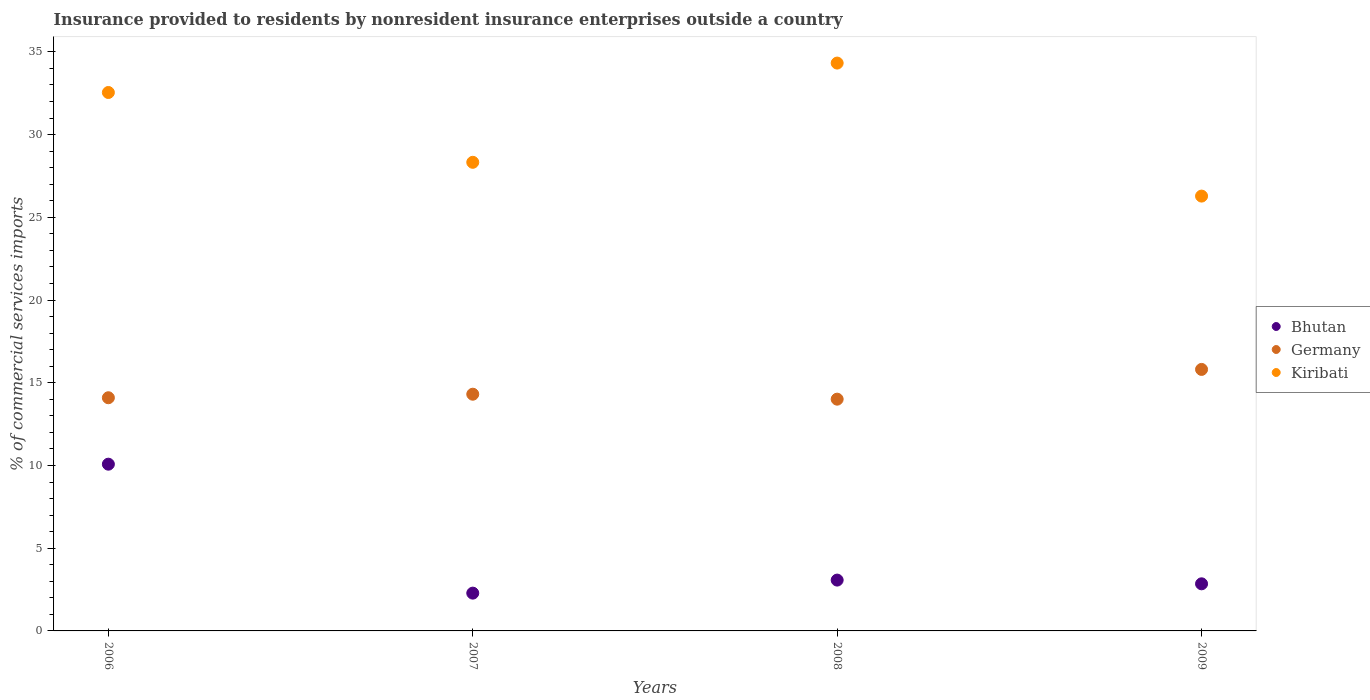What is the Insurance provided to residents in Kiribati in 2008?
Make the answer very short. 34.32. Across all years, what is the maximum Insurance provided to residents in Germany?
Your response must be concise. 15.81. Across all years, what is the minimum Insurance provided to residents in Kiribati?
Offer a very short reply. 26.28. In which year was the Insurance provided to residents in Bhutan minimum?
Make the answer very short. 2007. What is the total Insurance provided to residents in Bhutan in the graph?
Your answer should be compact. 18.28. What is the difference between the Insurance provided to residents in Bhutan in 2007 and that in 2008?
Provide a short and direct response. -0.79. What is the difference between the Insurance provided to residents in Germany in 2006 and the Insurance provided to residents in Kiribati in 2009?
Ensure brevity in your answer.  -12.19. What is the average Insurance provided to residents in Germany per year?
Ensure brevity in your answer.  14.55. In the year 2009, what is the difference between the Insurance provided to residents in Kiribati and Insurance provided to residents in Germany?
Keep it short and to the point. 10.48. What is the ratio of the Insurance provided to residents in Kiribati in 2006 to that in 2007?
Your answer should be very brief. 1.15. What is the difference between the highest and the second highest Insurance provided to residents in Kiribati?
Provide a short and direct response. 1.78. What is the difference between the highest and the lowest Insurance provided to residents in Kiribati?
Provide a short and direct response. 8.04. In how many years, is the Insurance provided to residents in Bhutan greater than the average Insurance provided to residents in Bhutan taken over all years?
Your answer should be compact. 1. How many dotlines are there?
Provide a short and direct response. 3. What is the difference between two consecutive major ticks on the Y-axis?
Your answer should be very brief. 5. Are the values on the major ticks of Y-axis written in scientific E-notation?
Offer a terse response. No. Does the graph contain any zero values?
Offer a very short reply. No. How many legend labels are there?
Make the answer very short. 3. What is the title of the graph?
Your answer should be compact. Insurance provided to residents by nonresident insurance enterprises outside a country. Does "East Asia (all income levels)" appear as one of the legend labels in the graph?
Offer a very short reply. No. What is the label or title of the Y-axis?
Make the answer very short. % of commercial services imports. What is the % of commercial services imports of Bhutan in 2006?
Keep it short and to the point. 10.08. What is the % of commercial services imports of Germany in 2006?
Ensure brevity in your answer.  14.09. What is the % of commercial services imports in Kiribati in 2006?
Provide a succinct answer. 32.55. What is the % of commercial services imports in Bhutan in 2007?
Give a very brief answer. 2.28. What is the % of commercial services imports of Germany in 2007?
Offer a very short reply. 14.31. What is the % of commercial services imports of Kiribati in 2007?
Make the answer very short. 28.33. What is the % of commercial services imports in Bhutan in 2008?
Provide a short and direct response. 3.07. What is the % of commercial services imports of Germany in 2008?
Your answer should be compact. 14.01. What is the % of commercial services imports in Kiribati in 2008?
Your response must be concise. 34.32. What is the % of commercial services imports in Bhutan in 2009?
Keep it short and to the point. 2.85. What is the % of commercial services imports in Germany in 2009?
Your answer should be compact. 15.81. What is the % of commercial services imports in Kiribati in 2009?
Offer a very short reply. 26.28. Across all years, what is the maximum % of commercial services imports in Bhutan?
Your answer should be very brief. 10.08. Across all years, what is the maximum % of commercial services imports in Germany?
Provide a succinct answer. 15.81. Across all years, what is the maximum % of commercial services imports of Kiribati?
Ensure brevity in your answer.  34.32. Across all years, what is the minimum % of commercial services imports in Bhutan?
Provide a short and direct response. 2.28. Across all years, what is the minimum % of commercial services imports of Germany?
Provide a short and direct response. 14.01. Across all years, what is the minimum % of commercial services imports of Kiribati?
Provide a short and direct response. 26.28. What is the total % of commercial services imports in Bhutan in the graph?
Offer a very short reply. 18.28. What is the total % of commercial services imports of Germany in the graph?
Make the answer very short. 58.22. What is the total % of commercial services imports in Kiribati in the graph?
Give a very brief answer. 121.48. What is the difference between the % of commercial services imports in Bhutan in 2006 and that in 2007?
Ensure brevity in your answer.  7.79. What is the difference between the % of commercial services imports in Germany in 2006 and that in 2007?
Your answer should be compact. -0.21. What is the difference between the % of commercial services imports of Kiribati in 2006 and that in 2007?
Offer a very short reply. 4.22. What is the difference between the % of commercial services imports of Bhutan in 2006 and that in 2008?
Keep it short and to the point. 7.01. What is the difference between the % of commercial services imports of Germany in 2006 and that in 2008?
Offer a terse response. 0.09. What is the difference between the % of commercial services imports of Kiribati in 2006 and that in 2008?
Your answer should be very brief. -1.78. What is the difference between the % of commercial services imports of Bhutan in 2006 and that in 2009?
Your answer should be compact. 7.23. What is the difference between the % of commercial services imports of Germany in 2006 and that in 2009?
Your answer should be compact. -1.71. What is the difference between the % of commercial services imports in Kiribati in 2006 and that in 2009?
Make the answer very short. 6.26. What is the difference between the % of commercial services imports in Bhutan in 2007 and that in 2008?
Your answer should be very brief. -0.79. What is the difference between the % of commercial services imports of Germany in 2007 and that in 2008?
Your response must be concise. 0.3. What is the difference between the % of commercial services imports of Kiribati in 2007 and that in 2008?
Provide a succinct answer. -6. What is the difference between the % of commercial services imports of Bhutan in 2007 and that in 2009?
Keep it short and to the point. -0.56. What is the difference between the % of commercial services imports in Germany in 2007 and that in 2009?
Give a very brief answer. -1.5. What is the difference between the % of commercial services imports of Kiribati in 2007 and that in 2009?
Provide a short and direct response. 2.04. What is the difference between the % of commercial services imports of Bhutan in 2008 and that in 2009?
Offer a terse response. 0.22. What is the difference between the % of commercial services imports in Germany in 2008 and that in 2009?
Your answer should be very brief. -1.8. What is the difference between the % of commercial services imports of Kiribati in 2008 and that in 2009?
Offer a very short reply. 8.04. What is the difference between the % of commercial services imports in Bhutan in 2006 and the % of commercial services imports in Germany in 2007?
Offer a terse response. -4.23. What is the difference between the % of commercial services imports of Bhutan in 2006 and the % of commercial services imports of Kiribati in 2007?
Ensure brevity in your answer.  -18.25. What is the difference between the % of commercial services imports of Germany in 2006 and the % of commercial services imports of Kiribati in 2007?
Offer a terse response. -14.23. What is the difference between the % of commercial services imports in Bhutan in 2006 and the % of commercial services imports in Germany in 2008?
Make the answer very short. -3.93. What is the difference between the % of commercial services imports in Bhutan in 2006 and the % of commercial services imports in Kiribati in 2008?
Your response must be concise. -24.24. What is the difference between the % of commercial services imports in Germany in 2006 and the % of commercial services imports in Kiribati in 2008?
Your response must be concise. -20.23. What is the difference between the % of commercial services imports in Bhutan in 2006 and the % of commercial services imports in Germany in 2009?
Keep it short and to the point. -5.73. What is the difference between the % of commercial services imports in Bhutan in 2006 and the % of commercial services imports in Kiribati in 2009?
Your response must be concise. -16.2. What is the difference between the % of commercial services imports in Germany in 2006 and the % of commercial services imports in Kiribati in 2009?
Offer a very short reply. -12.19. What is the difference between the % of commercial services imports of Bhutan in 2007 and the % of commercial services imports of Germany in 2008?
Your answer should be compact. -11.72. What is the difference between the % of commercial services imports of Bhutan in 2007 and the % of commercial services imports of Kiribati in 2008?
Your answer should be very brief. -32.04. What is the difference between the % of commercial services imports in Germany in 2007 and the % of commercial services imports in Kiribati in 2008?
Provide a succinct answer. -20.02. What is the difference between the % of commercial services imports in Bhutan in 2007 and the % of commercial services imports in Germany in 2009?
Make the answer very short. -13.52. What is the difference between the % of commercial services imports in Bhutan in 2007 and the % of commercial services imports in Kiribati in 2009?
Your response must be concise. -24. What is the difference between the % of commercial services imports in Germany in 2007 and the % of commercial services imports in Kiribati in 2009?
Your answer should be very brief. -11.98. What is the difference between the % of commercial services imports of Bhutan in 2008 and the % of commercial services imports of Germany in 2009?
Your answer should be compact. -12.73. What is the difference between the % of commercial services imports in Bhutan in 2008 and the % of commercial services imports in Kiribati in 2009?
Provide a short and direct response. -23.21. What is the difference between the % of commercial services imports in Germany in 2008 and the % of commercial services imports in Kiribati in 2009?
Give a very brief answer. -12.27. What is the average % of commercial services imports of Bhutan per year?
Provide a succinct answer. 4.57. What is the average % of commercial services imports of Germany per year?
Offer a terse response. 14.55. What is the average % of commercial services imports in Kiribati per year?
Provide a short and direct response. 30.37. In the year 2006, what is the difference between the % of commercial services imports in Bhutan and % of commercial services imports in Germany?
Make the answer very short. -4.02. In the year 2006, what is the difference between the % of commercial services imports in Bhutan and % of commercial services imports in Kiribati?
Ensure brevity in your answer.  -22.47. In the year 2006, what is the difference between the % of commercial services imports of Germany and % of commercial services imports of Kiribati?
Ensure brevity in your answer.  -18.45. In the year 2007, what is the difference between the % of commercial services imports in Bhutan and % of commercial services imports in Germany?
Offer a terse response. -12.02. In the year 2007, what is the difference between the % of commercial services imports of Bhutan and % of commercial services imports of Kiribati?
Offer a very short reply. -26.04. In the year 2007, what is the difference between the % of commercial services imports of Germany and % of commercial services imports of Kiribati?
Offer a terse response. -14.02. In the year 2008, what is the difference between the % of commercial services imports in Bhutan and % of commercial services imports in Germany?
Ensure brevity in your answer.  -10.94. In the year 2008, what is the difference between the % of commercial services imports of Bhutan and % of commercial services imports of Kiribati?
Give a very brief answer. -31.25. In the year 2008, what is the difference between the % of commercial services imports in Germany and % of commercial services imports in Kiribati?
Offer a very short reply. -20.31. In the year 2009, what is the difference between the % of commercial services imports of Bhutan and % of commercial services imports of Germany?
Your answer should be very brief. -12.96. In the year 2009, what is the difference between the % of commercial services imports of Bhutan and % of commercial services imports of Kiribati?
Your answer should be very brief. -23.44. In the year 2009, what is the difference between the % of commercial services imports in Germany and % of commercial services imports in Kiribati?
Your answer should be very brief. -10.48. What is the ratio of the % of commercial services imports of Bhutan in 2006 to that in 2007?
Your response must be concise. 4.41. What is the ratio of the % of commercial services imports in Germany in 2006 to that in 2007?
Your answer should be compact. 0.99. What is the ratio of the % of commercial services imports of Kiribati in 2006 to that in 2007?
Make the answer very short. 1.15. What is the ratio of the % of commercial services imports in Bhutan in 2006 to that in 2008?
Your response must be concise. 3.28. What is the ratio of the % of commercial services imports of Kiribati in 2006 to that in 2008?
Offer a very short reply. 0.95. What is the ratio of the % of commercial services imports of Bhutan in 2006 to that in 2009?
Your answer should be compact. 3.54. What is the ratio of the % of commercial services imports of Germany in 2006 to that in 2009?
Ensure brevity in your answer.  0.89. What is the ratio of the % of commercial services imports in Kiribati in 2006 to that in 2009?
Provide a short and direct response. 1.24. What is the ratio of the % of commercial services imports of Bhutan in 2007 to that in 2008?
Ensure brevity in your answer.  0.74. What is the ratio of the % of commercial services imports in Germany in 2007 to that in 2008?
Make the answer very short. 1.02. What is the ratio of the % of commercial services imports of Kiribati in 2007 to that in 2008?
Make the answer very short. 0.83. What is the ratio of the % of commercial services imports of Bhutan in 2007 to that in 2009?
Give a very brief answer. 0.8. What is the ratio of the % of commercial services imports of Germany in 2007 to that in 2009?
Offer a terse response. 0.91. What is the ratio of the % of commercial services imports of Kiribati in 2007 to that in 2009?
Offer a terse response. 1.08. What is the ratio of the % of commercial services imports of Bhutan in 2008 to that in 2009?
Make the answer very short. 1.08. What is the ratio of the % of commercial services imports in Germany in 2008 to that in 2009?
Your response must be concise. 0.89. What is the ratio of the % of commercial services imports of Kiribati in 2008 to that in 2009?
Keep it short and to the point. 1.31. What is the difference between the highest and the second highest % of commercial services imports in Bhutan?
Give a very brief answer. 7.01. What is the difference between the highest and the second highest % of commercial services imports in Germany?
Give a very brief answer. 1.5. What is the difference between the highest and the second highest % of commercial services imports in Kiribati?
Your answer should be very brief. 1.78. What is the difference between the highest and the lowest % of commercial services imports of Bhutan?
Ensure brevity in your answer.  7.79. What is the difference between the highest and the lowest % of commercial services imports in Germany?
Make the answer very short. 1.8. What is the difference between the highest and the lowest % of commercial services imports of Kiribati?
Give a very brief answer. 8.04. 